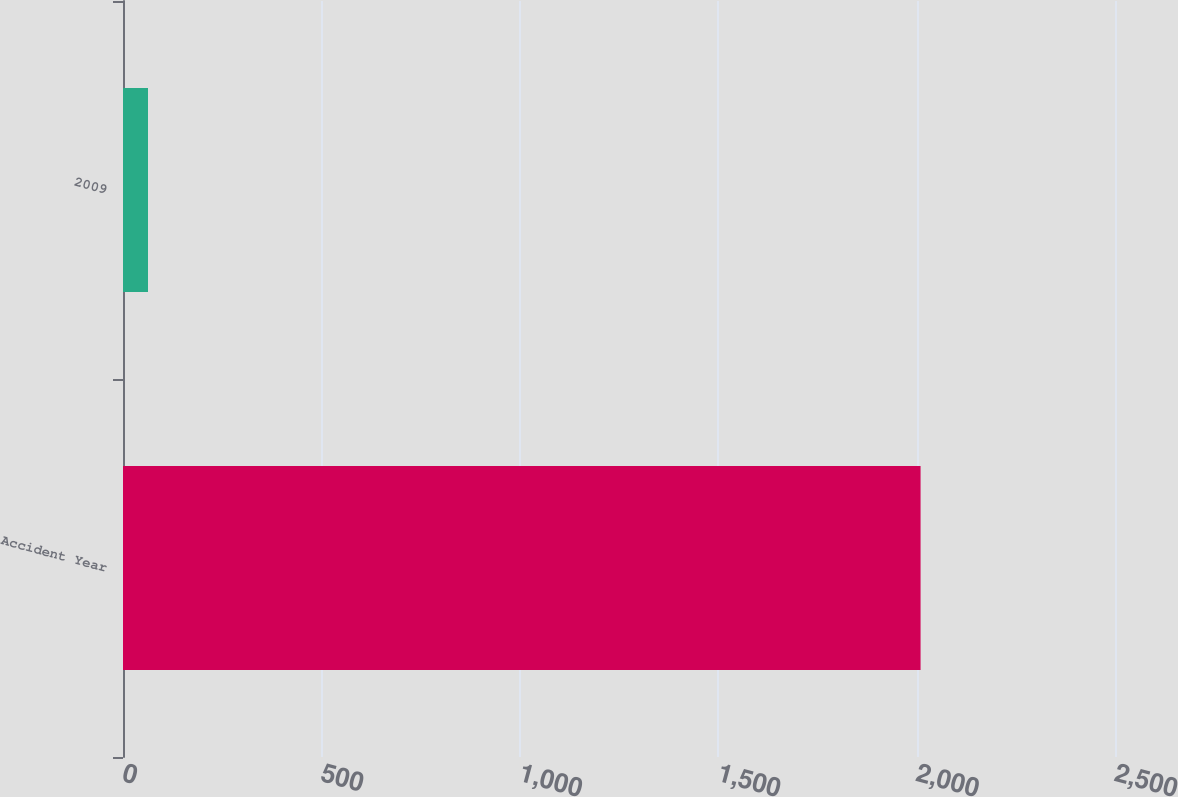Convert chart to OTSL. <chart><loc_0><loc_0><loc_500><loc_500><bar_chart><fcel>Accident Year<fcel>2009<nl><fcel>2010<fcel>63<nl></chart> 